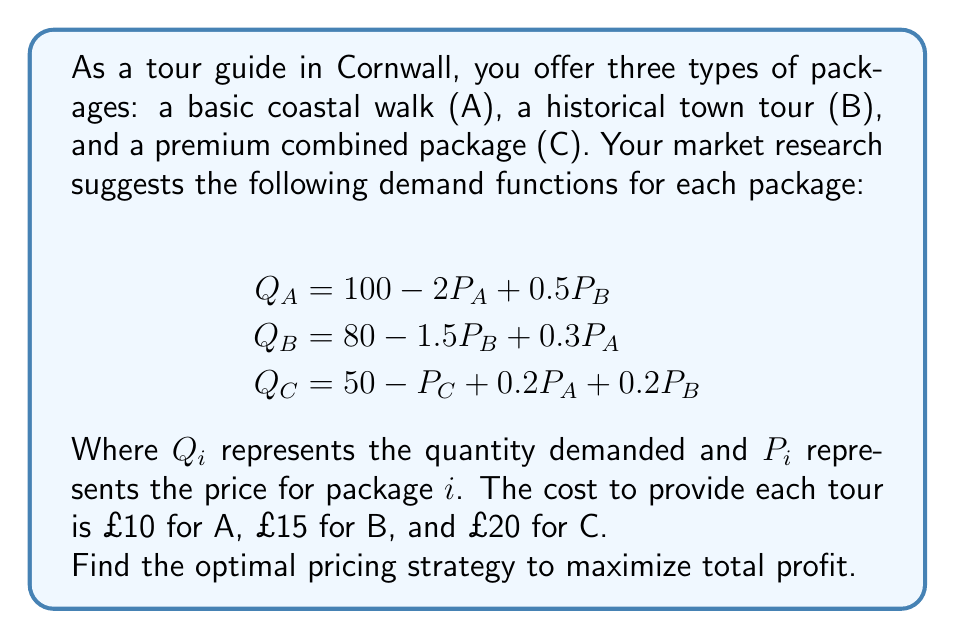Give your solution to this math problem. To solve this optimization problem, we'll follow these steps:

1) First, let's write the profit function. Profit is revenue minus cost:
   $$\pi = (P_A - 10)Q_A + (P_B - 15)Q_B + (P_C - 20)Q_C$$

2) Substitute the demand functions into the profit equation:
   $$\pi = (P_A - 10)(100 - 2P_A + 0.5P_B) + (P_B - 15)(80 - 1.5P_B + 0.3P_A) + (P_C - 20)(50 - P_C + 0.2P_A + 0.2P_B)$$

3) Expand this equation:
   $$\pi = 100P_A - 1000 - 2P_A^2 + 0.5P_AP_B - 10P_B + 250 + 80P_B - 1200 - 1.5P_B^2 + 0.3P_AP_B - 24P_A + 360 + 50P_C - 1000 - P_C^2 + 0.2P_AP_C + 0.2P_BP_C - 10P_A - 10P_B - 20$$

4) To find the maximum profit, we need to find where the partial derivatives with respect to $P_A$, $P_B$, and $P_C$ are all zero:

   $$\frac{\partial \pi}{\partial P_A} = 100 - 4P_A + 0.5P_B + 0.3P_B - 24 + 0.2P_C - 10 = 0$$
   $$\frac{\partial \pi}{\partial P_B} = 0.5P_A - 10 + 80 - 3P_B + 0.3P_A + 0.2P_C - 10 = 0$$
   $$\frac{\partial \pi}{\partial P_C} = 50 - 2P_C + 0.2P_A + 0.2P_B = 0$$

5) Simplify these equations:
   $$66 - 4P_A + 0.8P_B + 0.2P_C = 0$$
   $$60 + 0.8P_A - 3P_B + 0.2P_C = 0$$
   $$50 + 0.2P_A + 0.2P_B - 2P_C = 0$$

6) Solve this system of equations. This can be done using matrix methods or substitution. After solving, we get:
   $$P_A \approx 32.95$$
   $$P_B \approx 36.84$$
   $$P_C \approx 46.58$$

7) Round these to the nearest pound for practical pricing:
   $$P_A = £33$$
   $$P_B = £37$$
   $$P_C = £47$$
Answer: The optimal pricing strategy to maximize total profit is:
Package A (Coastal Walk): £33
Package B (Historical Town Tour): £37
Package C (Premium Combined Package): £47 